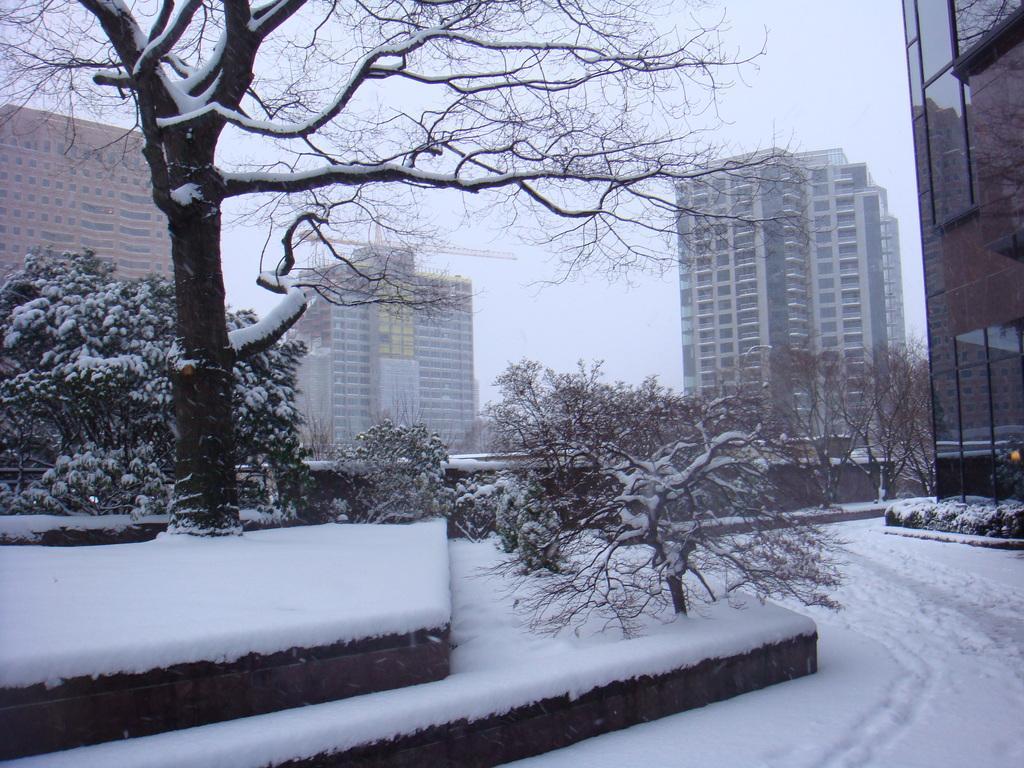Can you describe this image briefly? In the picture I can see the ground is covered with snow and there are few trees in the left corner which are covered with snow and there are buildings in the background. 